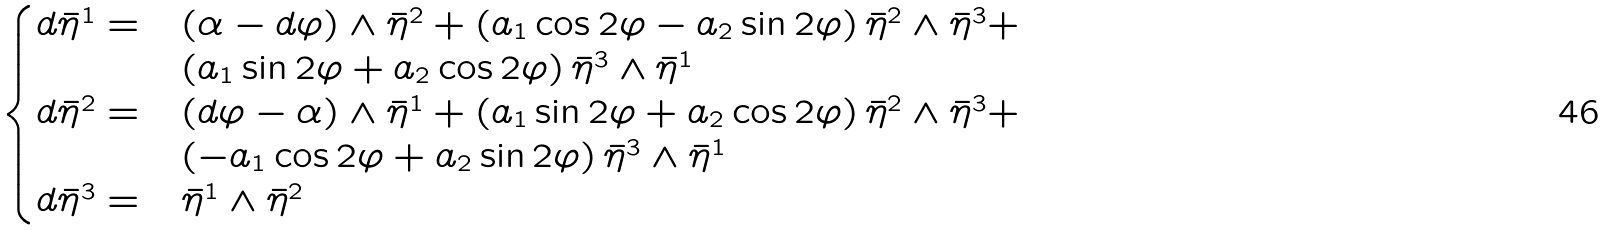Convert formula to latex. <formula><loc_0><loc_0><loc_500><loc_500>\begin{cases} d \bar { \eta } ^ { 1 } = & ( \alpha - d \varphi ) \wedge \bar { \eta } ^ { 2 } + \left ( a _ { 1 } \cos 2 \varphi - a _ { 2 } \sin 2 \varphi \right ) \bar { \eta } ^ { 2 } \wedge \bar { \eta } ^ { 3 } + \\ & \left ( a _ { 1 } \sin 2 \varphi + a _ { 2 } \cos 2 \varphi \right ) \bar { \eta } ^ { 3 } \wedge \bar { \eta } ^ { 1 } \\ d \bar { \eta } ^ { 2 } = & ( d \varphi - \alpha ) \wedge \bar { \eta } ^ { 1 } + \left ( a _ { 1 } \sin 2 \varphi + a _ { 2 } \cos 2 \varphi \right ) \bar { \eta } ^ { 2 } \wedge \bar { \eta } ^ { 3 } + \\ & \left ( - a _ { 1 } \cos 2 \varphi + a _ { 2 } \sin 2 \varphi \right ) \bar { \eta } ^ { 3 } \wedge \bar { \eta } ^ { 1 } \\ d \bar { \eta } ^ { 3 } = & \bar { \eta } ^ { 1 } \wedge \bar { \eta } ^ { 2 } \end{cases}</formula> 